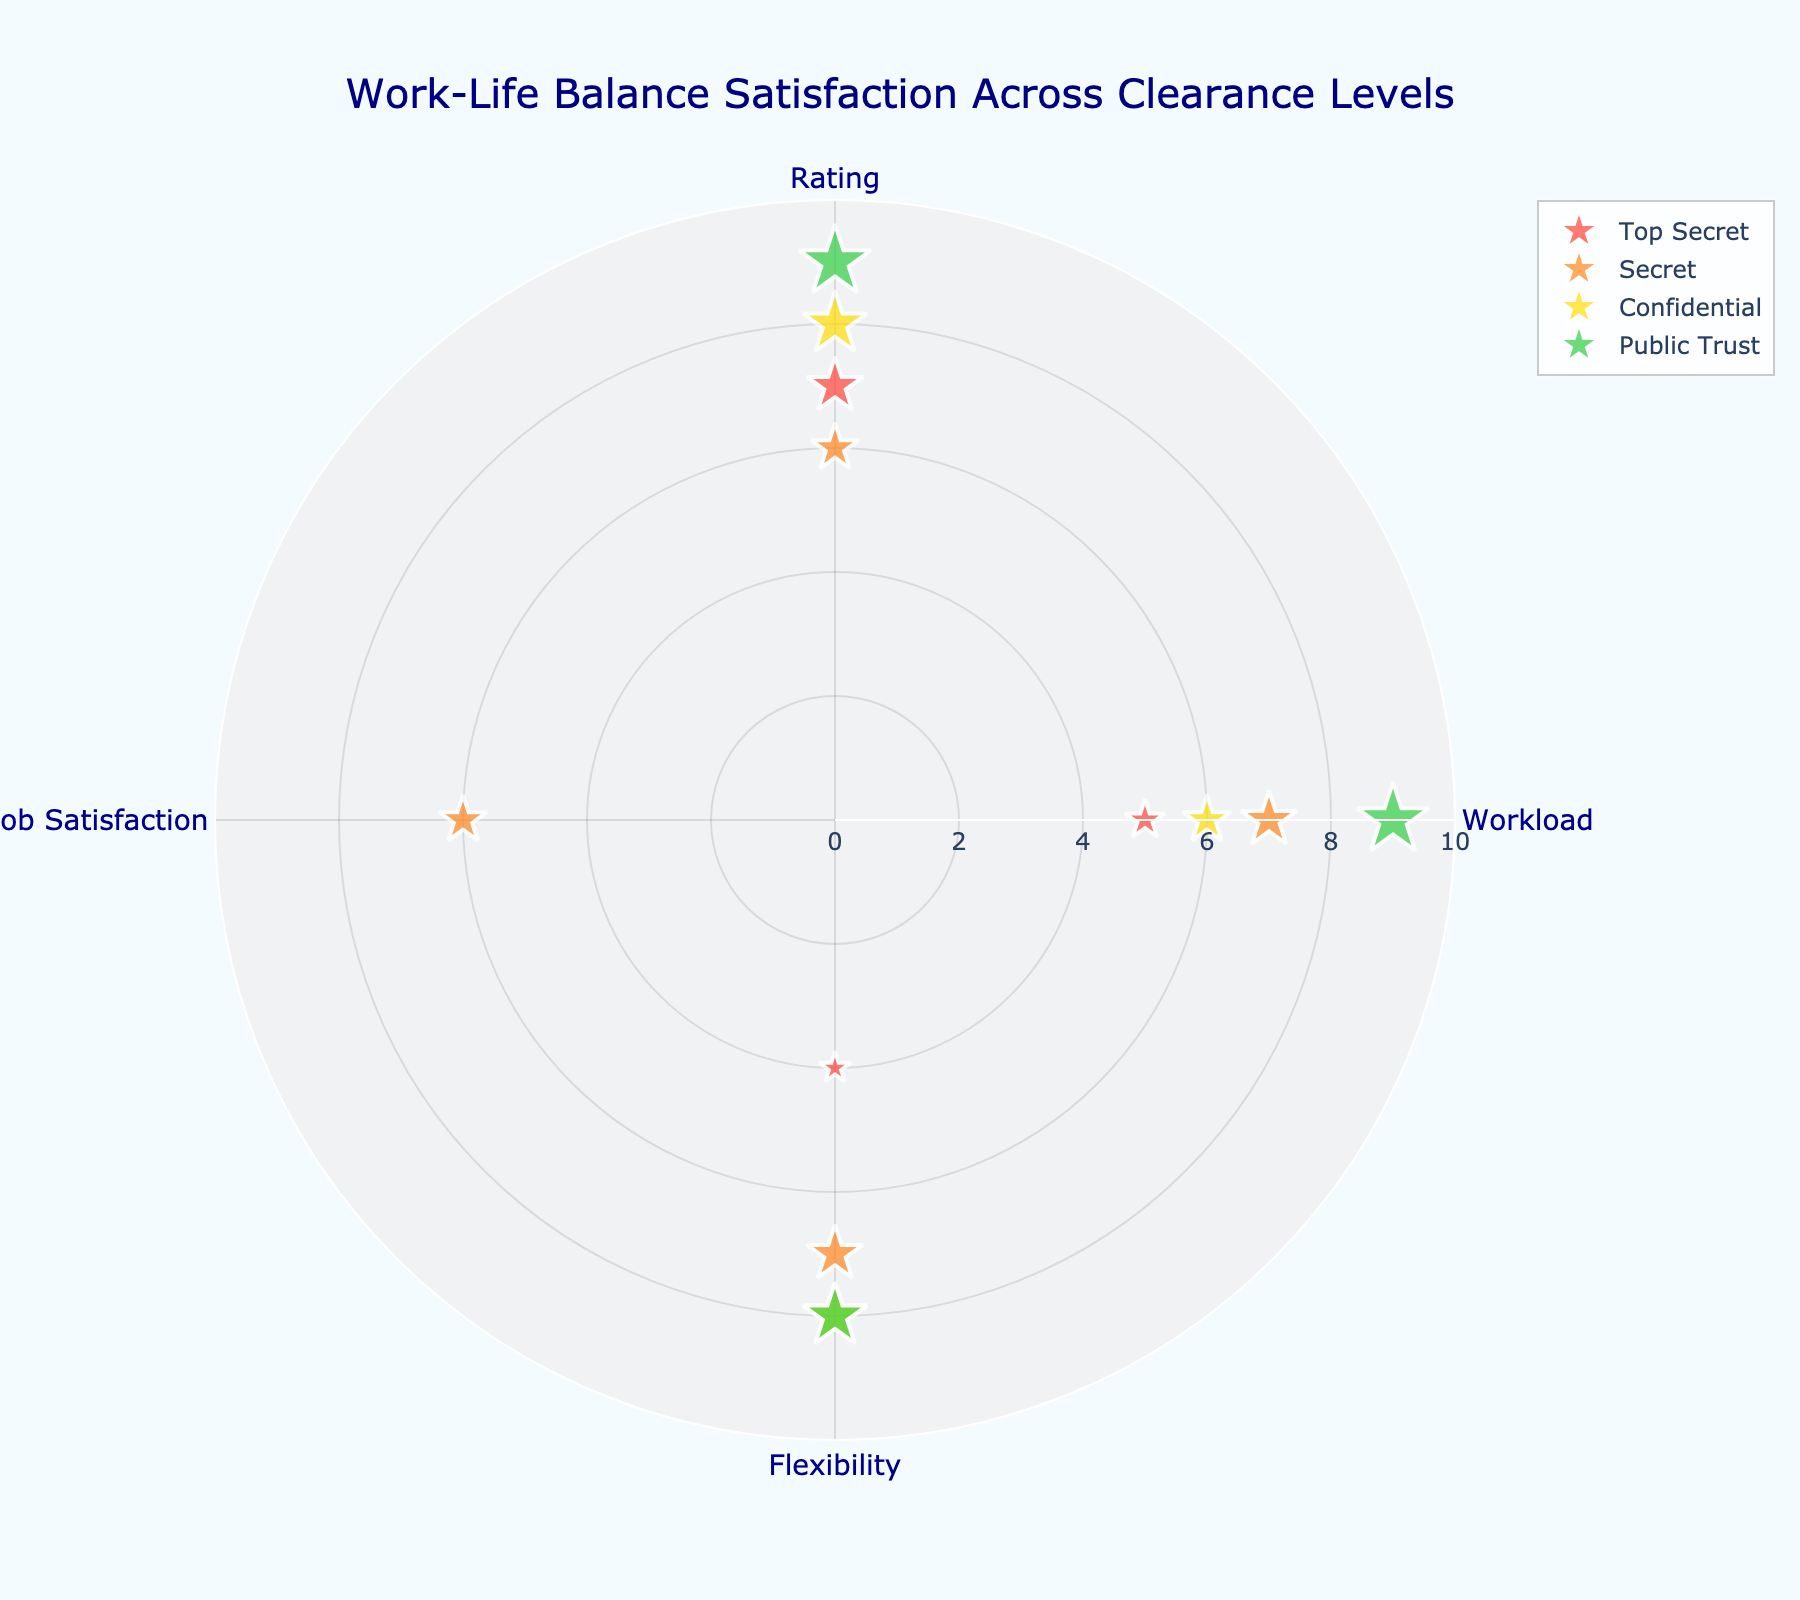Which clearance level group has the highest average rating? To find the highest average rating, calculate the average rating for each clearance level group. Top Secret: (7 + 5 + 4) / 3 = 5.33, Secret: (6 + 7 + 7 + 6) / 4 = 6.5, Confidential: (8 + 6 + 8) / 3 = 7.33, Public Trust: (9 + 9 + 8) / 3 = 8.67. Public Trust has the highest average rating at 8.67.
Answer: Public Trust What is the total number of employees displayed in the chart? Count the total number of data points in the figure. By counting each point from the provided data, we find there are 13 employees.
Answer: 13 How does the flexibility rating for Public Trust employees compare with that of Top Secret employees? To answer this, examine the flexibility ratings for each group. Public Trust: 3 data points with flexibility 5, 5, 5. Top Secret: 3 data points with flexibility 3, 2, 2. Public Trust employees have higher flexibility ratings than Top Secret employees.
Answer: Higher Which clearance level has the highest workload? Compare the average workload of each clearance level. Top Secret: (40 + 45 + 50) / 3 = 45, Secret: (35 + 38 + 36 + 37) / 4 = 36.5, Confidential: (30 + 32 + 28) / 3 = 30, Public Trust: (25 + 27 + 29) / 3 = 27. Public Trust has the highest average workload at 45.
Answer: Top Secret What is the average job satisfaction for Secret level employees? Calculate the average of the job satisfaction ratings for Secret level employees. The ratings are 6, 6, 6. Sum them (6 + 6 + 6) = 18, then divide by 3.
Answer: 6 Which clearance level has the most number of employees? Look at the number of data points for each group. Top Secret: 3, Secret: 4, Confidential: 3, Public Trust: 3. Secret level has the most employees at 4.
Answer: Secret What is the flexibility rating of Emily Green? Identify Emily Green from the data, she is a Confidential level employee with a flexibility rating of 4.
Answer: 4 Which clearance level group has the widest range of rating values? Calculate the range (maximum - minimum) of ratings for each group. Top Secret: max 7, min 4, range 3. Secret: max 7, min 6, range 1. Confidential: max 8, min 6, range 2. Public Trust: max 9, min 8, range 1. Top Secret has the widest range with 3.
Answer: Top Secret How many employees have a workload rating under 30? Look at the data points and count how many have a workload under 30. Susan White (25), William Martinez (27), Christopher Rodriguez (29). There are 3 employees.
Answer: 3 